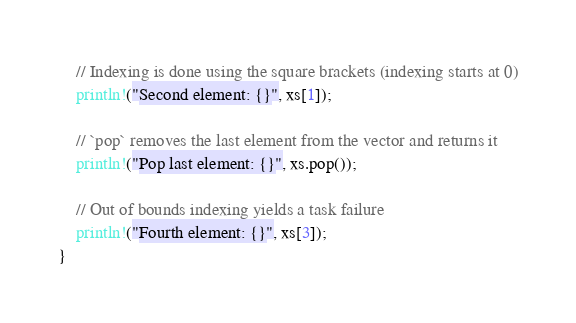<code> <loc_0><loc_0><loc_500><loc_500><_Rust_>    // Indexing is done using the square brackets (indexing starts at 0)
    println!("Second element: {}", xs[1]);

    // `pop` removes the last element from the vector and returns it
    println!("Pop last element: {}", xs.pop());

    // Out of bounds indexing yields a task failure
    println!("Fourth element: {}", xs[3]);
}
</code> 